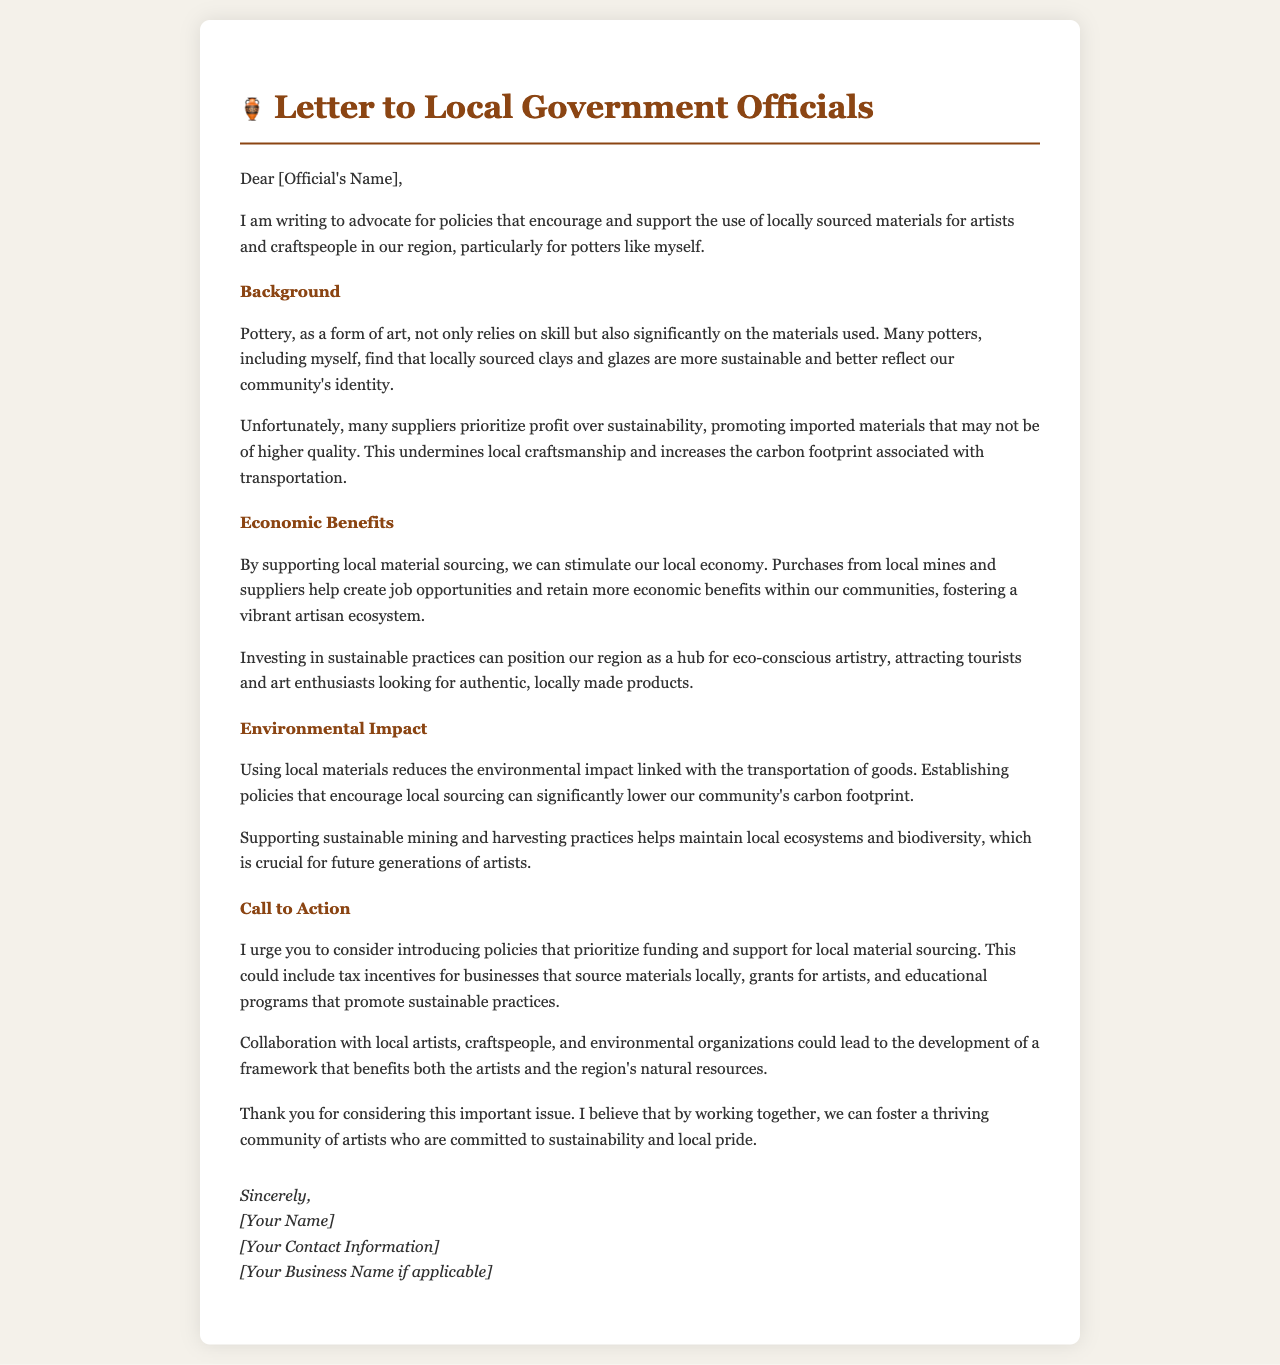What is the purpose of the letter? The letter advocates for policies that encourage and support the use of locally sourced materials for artists and craftspeople in the region.
Answer: advocate for local material sourcing Who is the letter addressed to? The letter is addressed to local government officials, indicated by "Dear [Official's Name]."
Answer: local government officials What economic benefit is mentioned in the letter? The letter mentions that supporting local material sourcing can stimulate the local economy and create job opportunities.
Answer: stimulate local economy What environmental impact is discussed? The document discusses that using local materials reduces the environmental impact linked with the transportation of goods.
Answer: reduces carbon footprint What specific call to action is suggested in the letter? The letter urges the introduction of policies that prioritize funding and support for local material sourcing.
Answer: introduce supportive policies Which art form is specifically referenced in the letter? The letter specifically references pottery as the art form relevant to the author's advocacy.
Answer: pottery How does the letter describe supplier practices? Suppliers are described as prioritizing profit over sustainability, promoting imported materials.
Answer: prioritize profit over sustainability What aim does the letter suggest for the region in the context of artistry? The letter suggests that investing in sustainable practices could position the region as a hub for eco-conscious artistry.
Answer: hub for eco-conscious artistry 